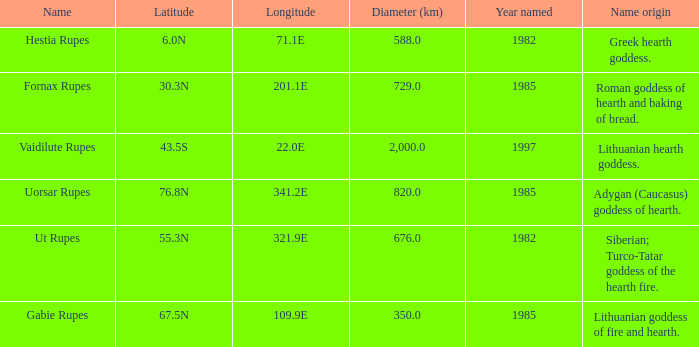At a latitude of 71.1e, what is the feature's name origin? Greek hearth goddess. 